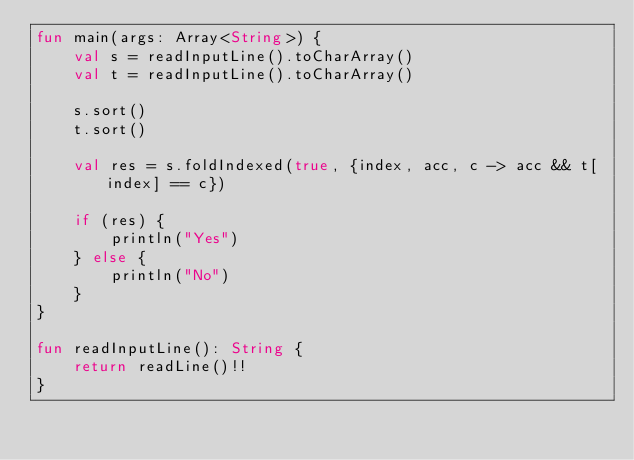Convert code to text. <code><loc_0><loc_0><loc_500><loc_500><_Kotlin_>fun main(args: Array<String>) {
    val s = readInputLine().toCharArray()
    val t = readInputLine().toCharArray()
    
    s.sort()
    t.sort()
    
    val res = s.foldIndexed(true, {index, acc, c -> acc && t[index] == c})
    
    if (res) {
        println("Yes")
    } else {
        println("No")
    }
}
 
fun readInputLine(): String {
    return readLine()!!
}
</code> 